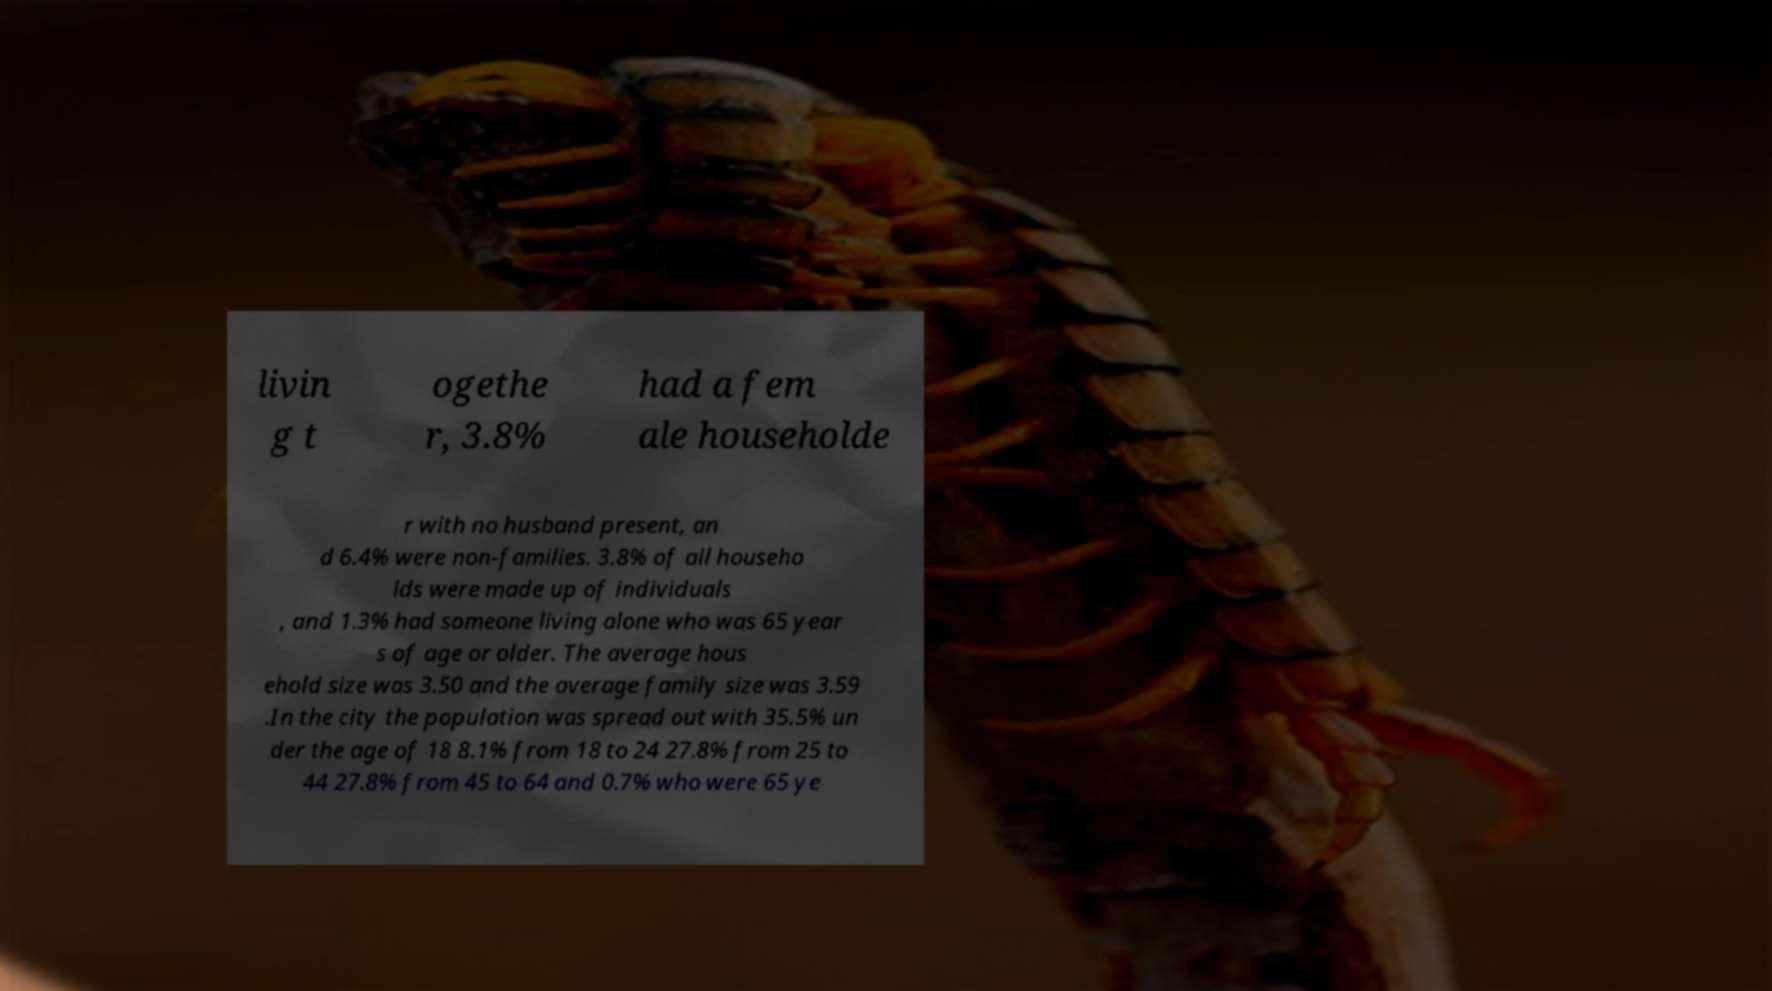Please identify and transcribe the text found in this image. livin g t ogethe r, 3.8% had a fem ale householde r with no husband present, an d 6.4% were non-families. 3.8% of all househo lds were made up of individuals , and 1.3% had someone living alone who was 65 year s of age or older. The average hous ehold size was 3.50 and the average family size was 3.59 .In the city the population was spread out with 35.5% un der the age of 18 8.1% from 18 to 24 27.8% from 25 to 44 27.8% from 45 to 64 and 0.7% who were 65 ye 